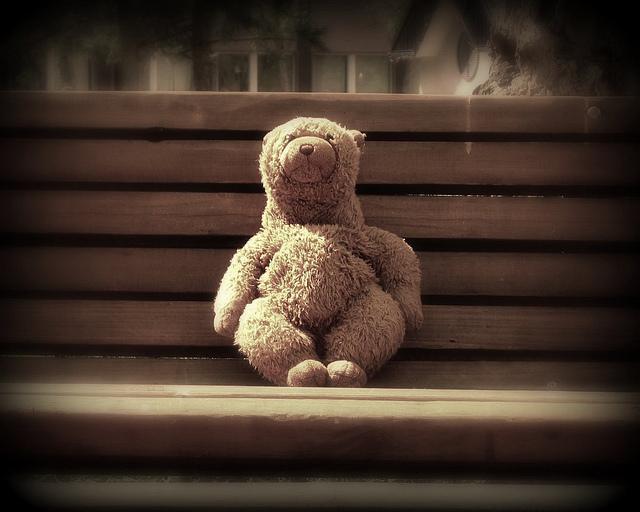What is the bench made of?
Answer briefly. Wood. What color is the bear's fur?
Keep it brief. Tan. Is the bear black, brown, or white?
Keep it brief. Brown. What is the bear sitting on?
Quick response, please. Bench. Is this a real bear?
Give a very brief answer. No. 